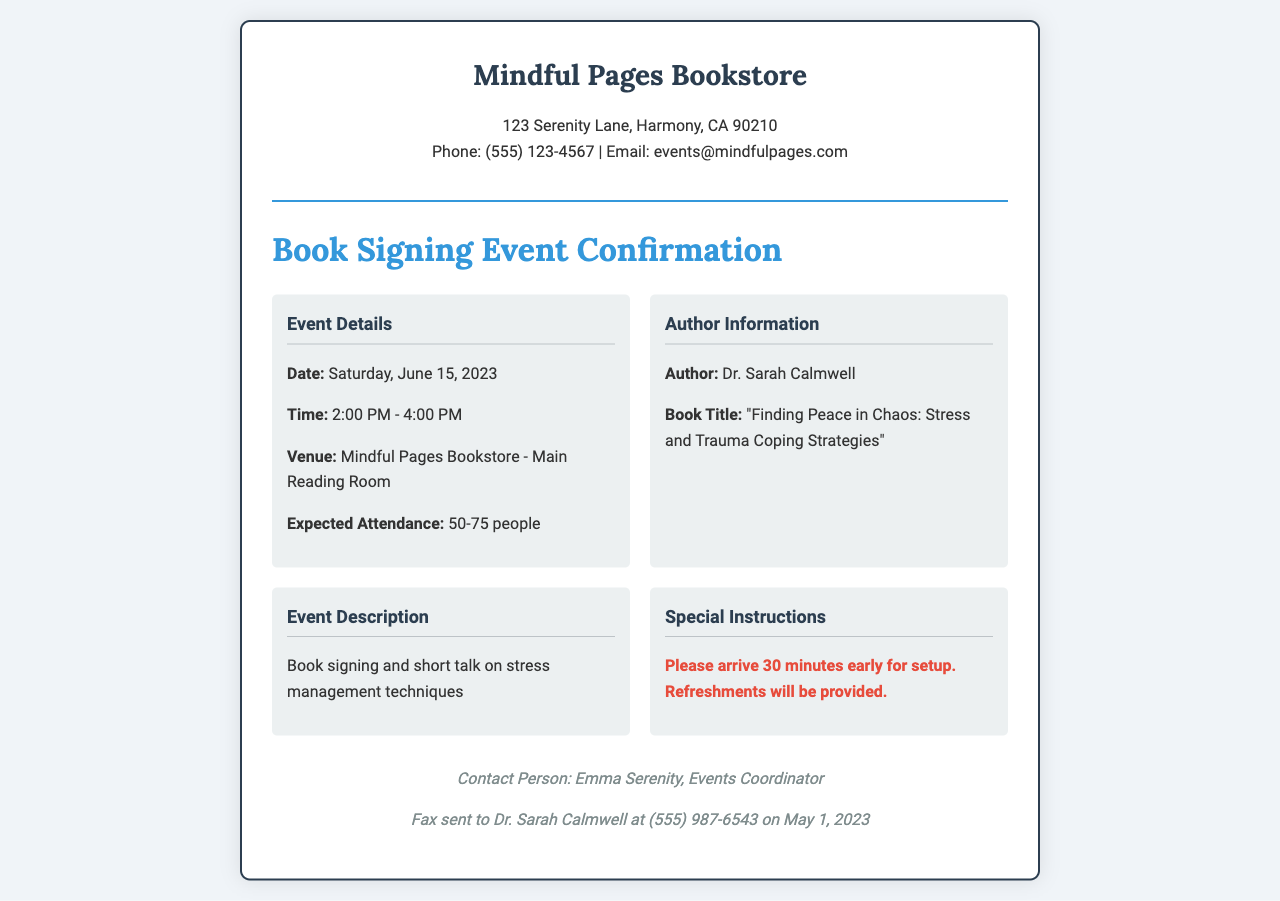What is the date of the event? The date of the event is explicitly mentioned in the document as Saturday, June 15, 2023.
Answer: Saturday, June 15, 2023 What is the time of the book signing? The time is specified in the document as 2:00 PM - 4:00 PM.
Answer: 2:00 PM - 4:00 PM Who is the author of the book being signed? The author's name appears in the document as Dr. Sarah Calmwell.
Answer: Dr. Sarah Calmwell What is the title of the book? The title of the book is highlighted in the document as "Finding Peace in Chaos: Stress and Trauma Coping Strategies".
Answer: "Finding Peace in Chaos: Stress and Trauma Coping Strategies" How many people are expected to attend? The document states the expected attendance as 50-75 people.
Answer: 50-75 people What special instructions are provided for the event? Special instructions in the document include the note to arrive 30 minutes early for setup.
Answer: Please arrive 30 minutes early for setup What type of event is being held? The document describes the event as a book signing and short talk on stress management techniques.
Answer: Book signing and short talk on stress management techniques What is the venue for the event? The venue is clearly mentioned in the document as Mindful Pages Bookstore - Main Reading Room.
Answer: Mindful Pages Bookstore - Main Reading Room Who is the contact person for the event? The contact person is specified in the document as Emma Serenity, Events Coordinator.
Answer: Emma Serenity, Events Coordinator 